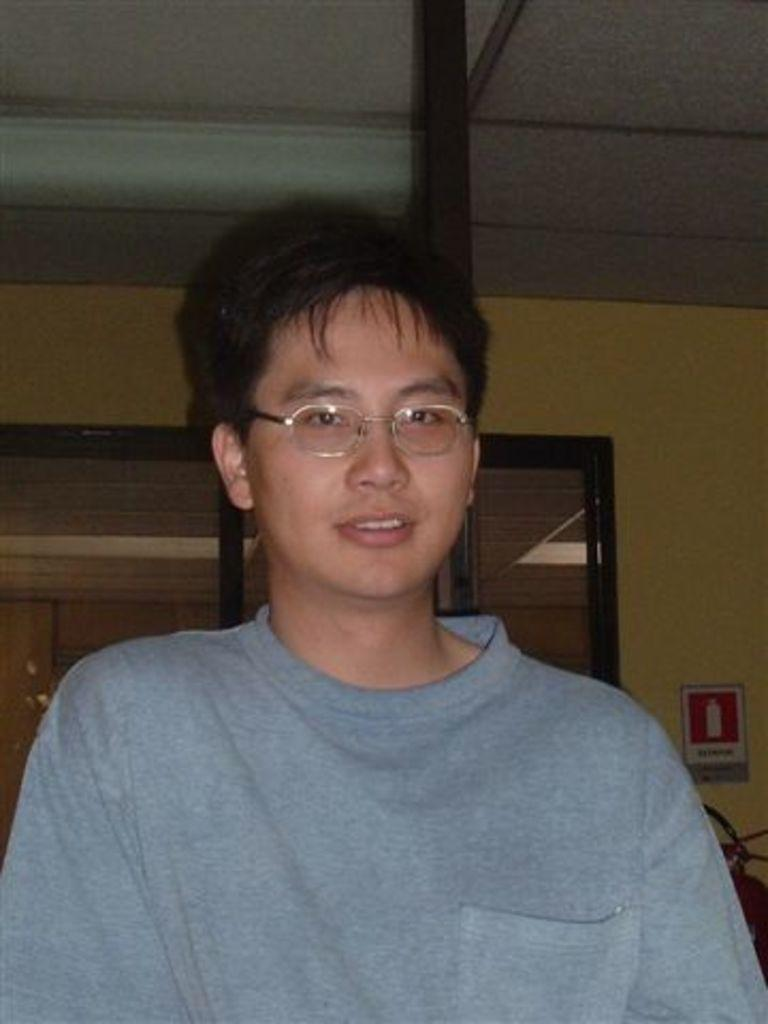What is the main subject in the foreground of the image? There is a man in the foreground of the image. What can be observed about the man's appearance? The man is wearing glasses and has black hair. How many babies are crawling on the land in the image? There are no babies or land present in the image; it features a man with glasses and black hair. 